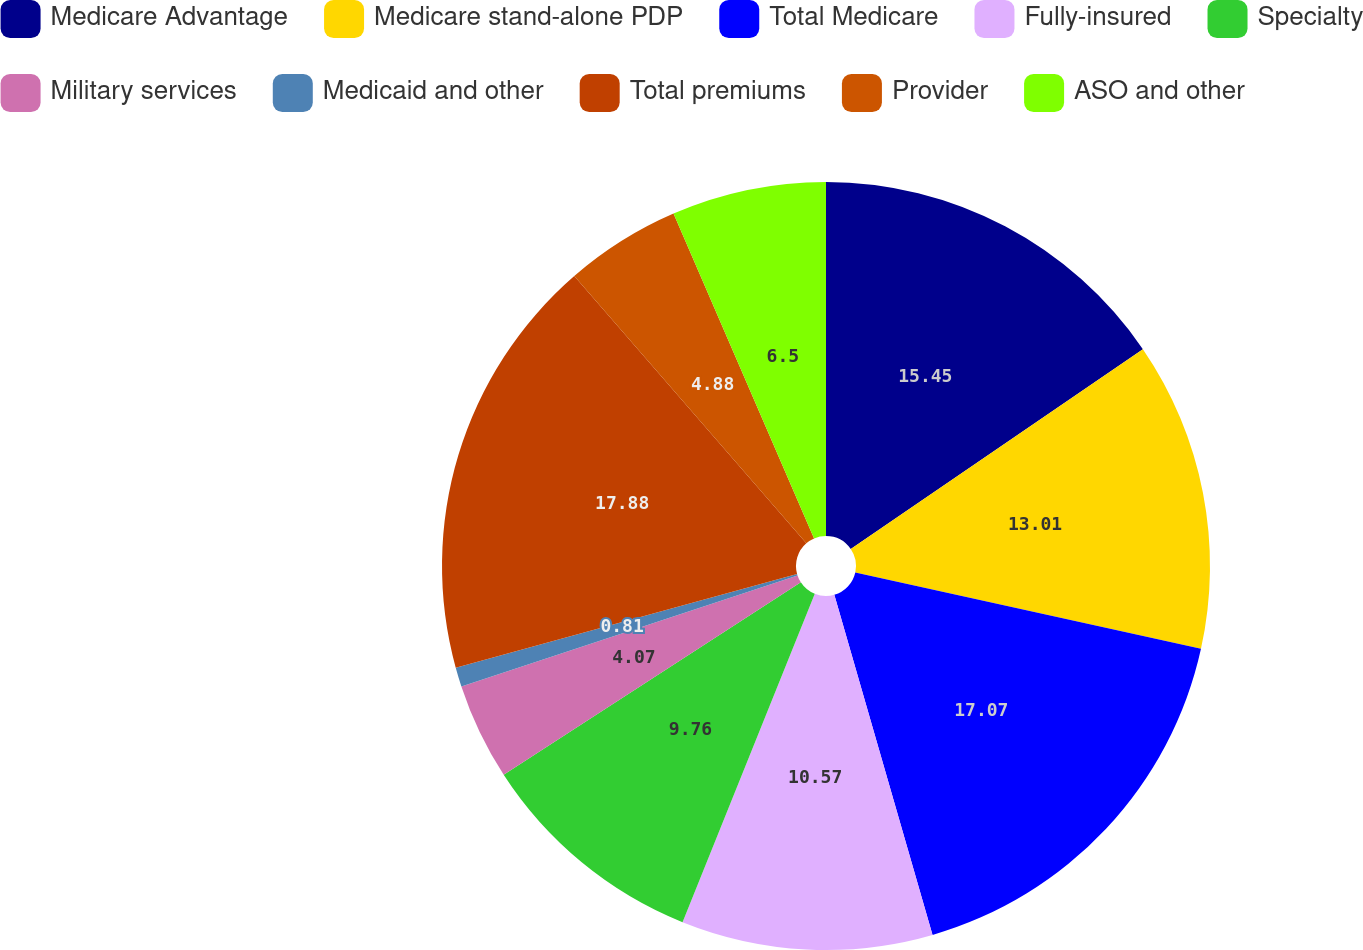Convert chart. <chart><loc_0><loc_0><loc_500><loc_500><pie_chart><fcel>Medicare Advantage<fcel>Medicare stand-alone PDP<fcel>Total Medicare<fcel>Fully-insured<fcel>Specialty<fcel>Military services<fcel>Medicaid and other<fcel>Total premiums<fcel>Provider<fcel>ASO and other<nl><fcel>15.45%<fcel>13.01%<fcel>17.07%<fcel>10.57%<fcel>9.76%<fcel>4.07%<fcel>0.81%<fcel>17.89%<fcel>4.88%<fcel>6.5%<nl></chart> 